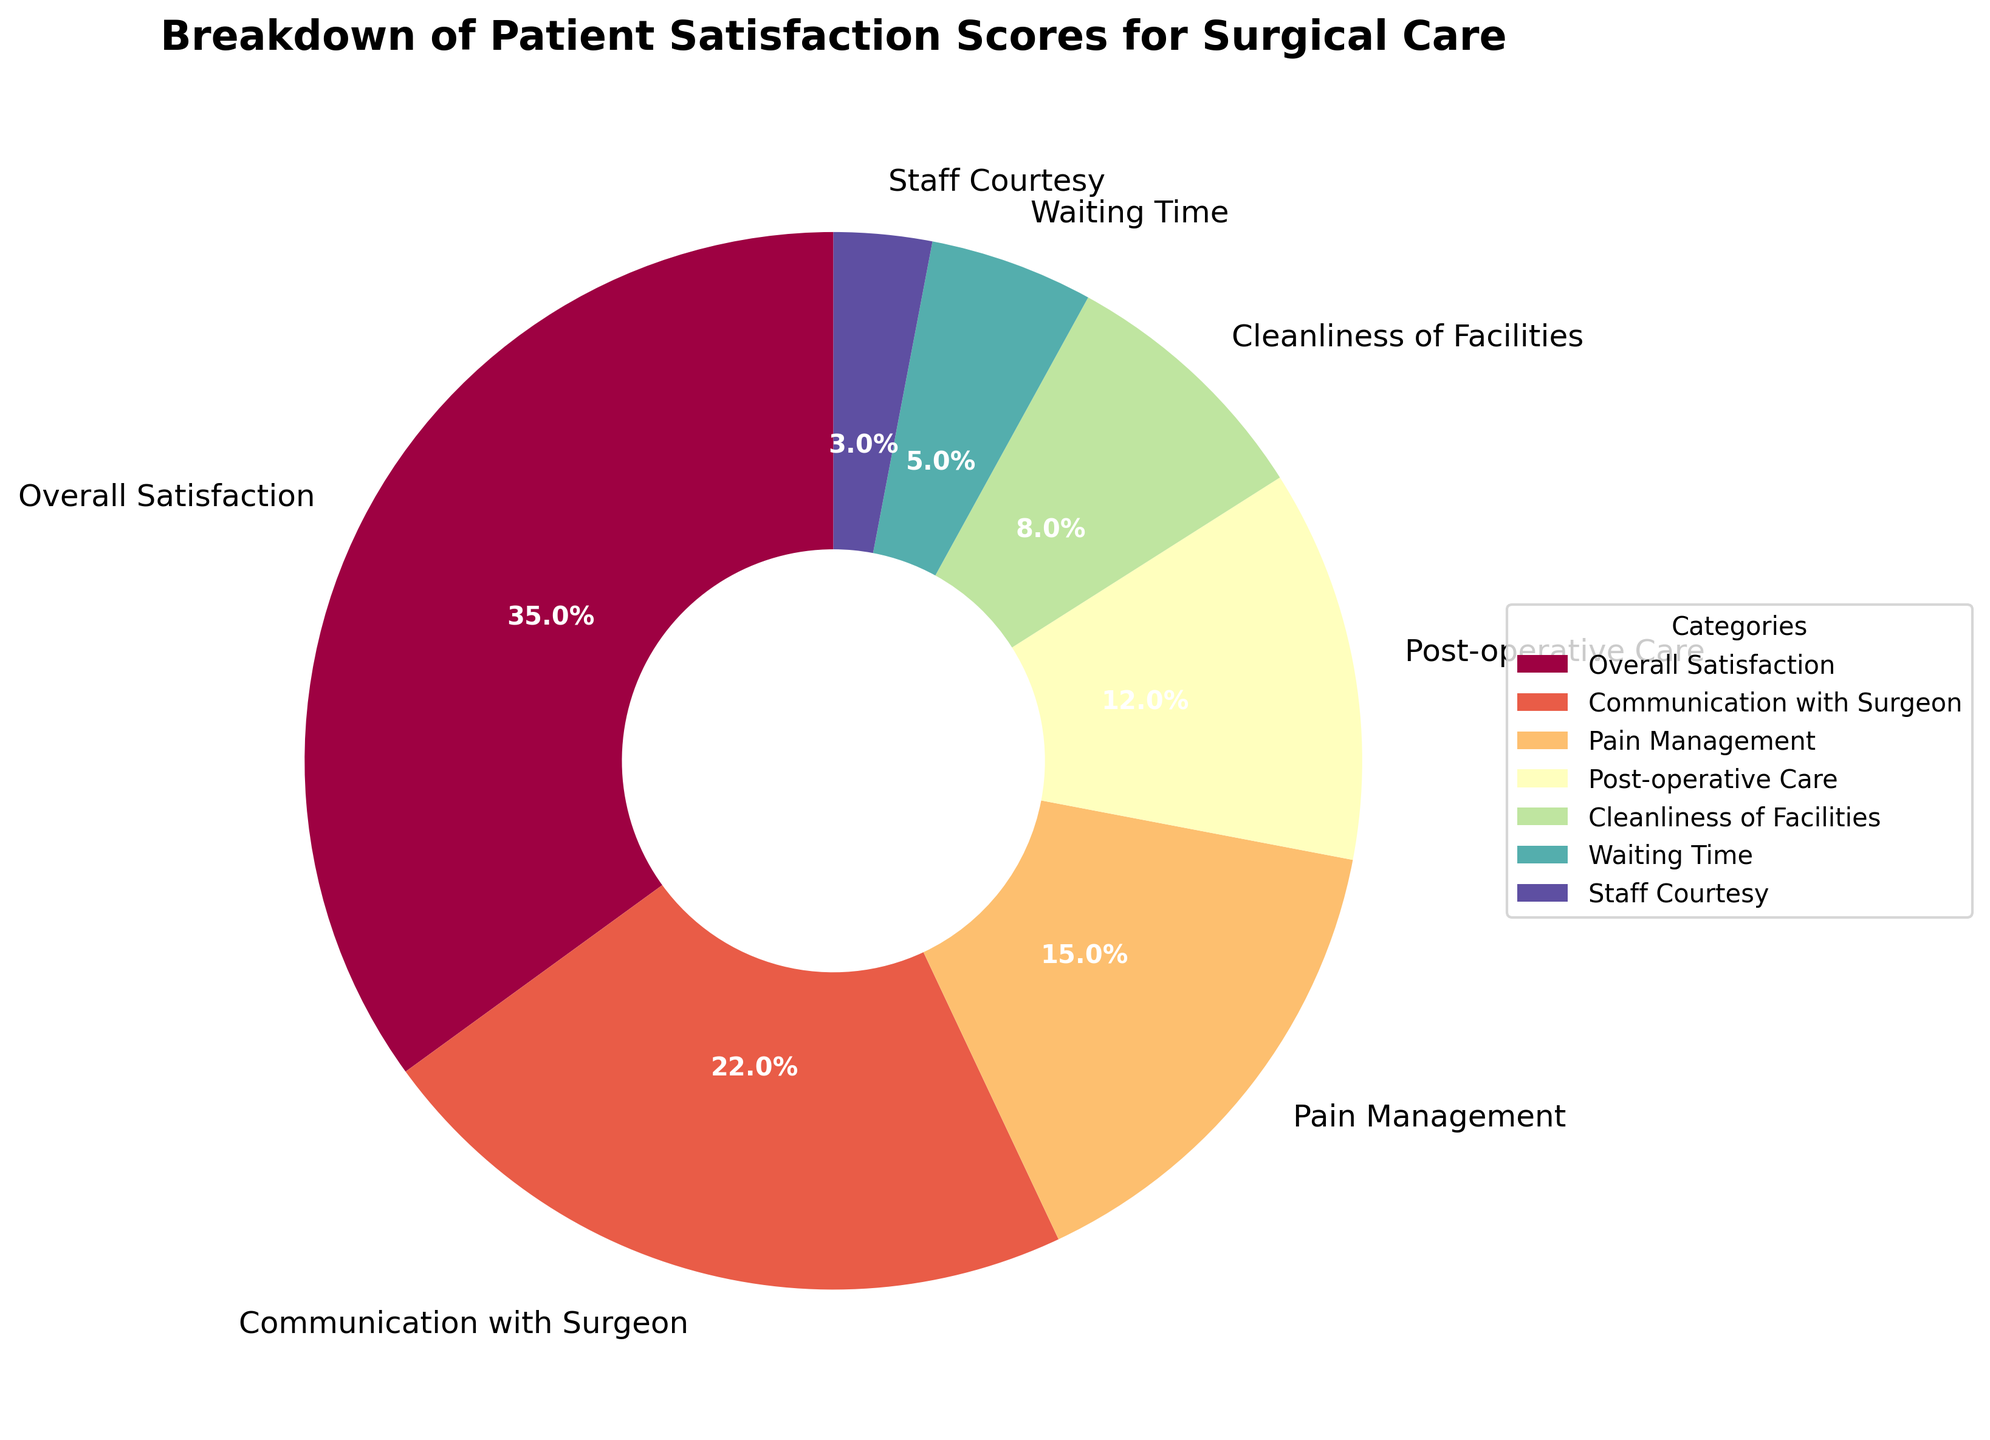What's the category with the highest percentage of patient satisfaction? The category with the highest percentage can be identified by looking at the largest wedge in the pie chart. The title of the wedge matching the highest percentage (35%) is "Overall Satisfaction".
Answer: Overall Satisfaction Which category has a smaller percentage: Pain Management or Post-operative Care? By comparing the percentages labelled on the pie chart, Pain Management has 15%, and Post-operative Care has 12%. Since 12% is smaller than 15%, Post-operative Care has a smaller percentage.
Answer: Post-operative Care What is the combined percentage of "Pain Management," "Cleanliness of Facilities," and "Waiting Time"? To find this, sum the percentages for Pain Management (15%), Cleanliness of Facilities (8%), and Waiting Time (5%). The calculation is 15 + 8 + 5 = 28%.
Answer: 28% How much higher is the percentage for "Overall Satisfaction" compared to "Communication with Surgeon"? Subtract the percentage of Communication with Surgeon (22%) from that of Overall Satisfaction (35%). The calculation is 35 - 22 = 13%.
Answer: 13% Which category has the smallest represented percentage, and how much is it? By identifying the smallest wedge in the pie chart, it corresponds to the category "Staff Courtesy" with a percentage of 3%.
Answer: Staff Courtesy, 3% What is the percentage difference between the "Cleanliness of Facilities" and "Waiting Time"? Subtract the percentage of Waiting Time (5%) from Cleanliness of Facilities (8%). The calculation is 8 - 5 = 3%.
Answer: 3% How do the percentages of "Post-operative Care" and "Cleanliness of Facilities" compare to the percentage of "Overall Satisfaction"? Sum the percentages of Post-operative Care (12%) and Cleanliness of Facilities (8%) to get 12 + 8 = 20%. Compare this to the percentage of Overall Satisfaction (35%). 35% is greater than 20%.
Answer: Overall Satisfaction is greater than the combined percentages of Post-operative Care and Cleanliness of Facilities Which categories together make up exactly half (50%) of the total satisfaction score? Add the percentages of "Overall Satisfaction" (35%) and "Communication with Surgeon" (22%) to get 35 + 22 = 57%, which is greater than 50%. Try the next largest combinations: "Overall Satisfaction" (35%) and "Pain Management" (15%) make 35 + 15 = 50%.
Answer: Overall Satisfaction and Pain Management What is the approximate color of the wedge representing "Communication with Surgeon"? By looking at the pie chart and identifying the specific color associated with the "Communication with Surgeon" label, it can be seen that the wedge is colored a shade of orange.
Answer: Orange Which has a larger percentage: "Post-operative Care" or "Cleanliness of Facilities" plus "Staff Courtesy"? First, sum the percentages for Cleanliness of Facilities (8%) and Staff Courtesy (3%), getting 8 + 3 = 11%. Compare this with Post-operative Care (12%). Since 12% is larger than 11%, Post-operative Care has a larger percentage.
Answer: Post-operative Care 